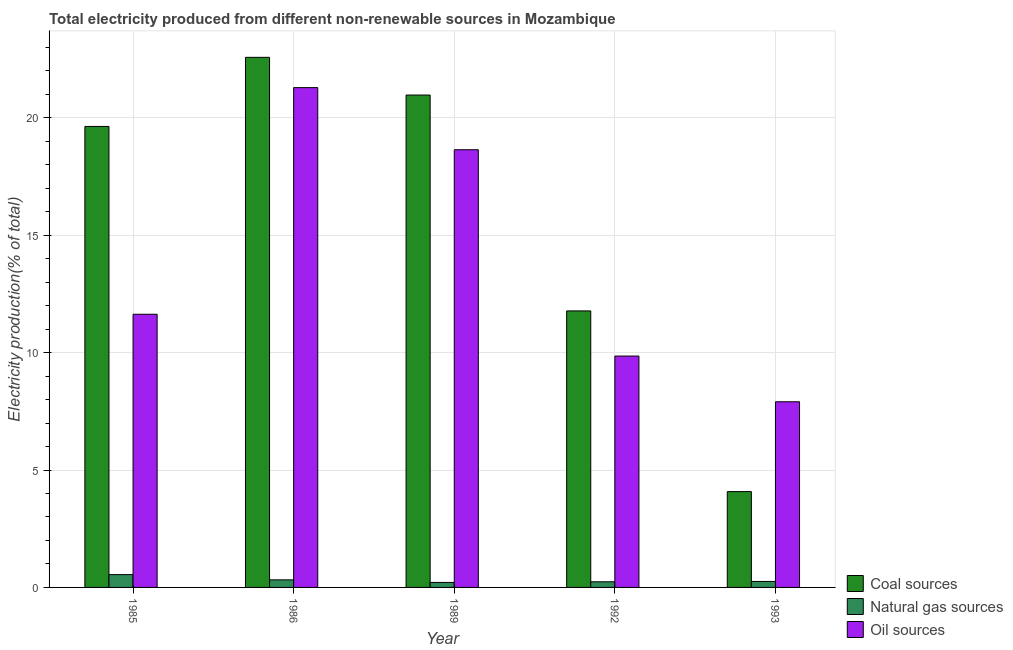How many groups of bars are there?
Your answer should be compact. 5. Are the number of bars per tick equal to the number of legend labels?
Keep it short and to the point. Yes. How many bars are there on the 1st tick from the right?
Keep it short and to the point. 3. What is the percentage of electricity produced by oil sources in 1986?
Your answer should be compact. 21.29. Across all years, what is the maximum percentage of electricity produced by natural gas?
Your answer should be very brief. 0.55. Across all years, what is the minimum percentage of electricity produced by oil sources?
Offer a very short reply. 7.91. In which year was the percentage of electricity produced by natural gas minimum?
Your answer should be compact. 1989. What is the total percentage of electricity produced by coal in the graph?
Keep it short and to the point. 79.05. What is the difference between the percentage of electricity produced by oil sources in 1989 and that in 1992?
Your answer should be very brief. 8.79. What is the difference between the percentage of electricity produced by oil sources in 1985 and the percentage of electricity produced by coal in 1992?
Your answer should be compact. 1.78. What is the average percentage of electricity produced by natural gas per year?
Ensure brevity in your answer.  0.32. In the year 1992, what is the difference between the percentage of electricity produced by natural gas and percentage of electricity produced by oil sources?
Keep it short and to the point. 0. What is the ratio of the percentage of electricity produced by oil sources in 1989 to that in 1992?
Keep it short and to the point. 1.89. Is the percentage of electricity produced by oil sources in 1985 less than that in 1993?
Provide a succinct answer. No. What is the difference between the highest and the second highest percentage of electricity produced by oil sources?
Ensure brevity in your answer.  2.65. What is the difference between the highest and the lowest percentage of electricity produced by oil sources?
Offer a terse response. 13.38. In how many years, is the percentage of electricity produced by oil sources greater than the average percentage of electricity produced by oil sources taken over all years?
Keep it short and to the point. 2. What does the 2nd bar from the left in 1993 represents?
Make the answer very short. Natural gas sources. What does the 1st bar from the right in 1993 represents?
Make the answer very short. Oil sources. Is it the case that in every year, the sum of the percentage of electricity produced by coal and percentage of electricity produced by natural gas is greater than the percentage of electricity produced by oil sources?
Your answer should be compact. No. How many years are there in the graph?
Make the answer very short. 5. What is the difference between two consecutive major ticks on the Y-axis?
Give a very brief answer. 5. Are the values on the major ticks of Y-axis written in scientific E-notation?
Provide a short and direct response. No. Does the graph contain grids?
Ensure brevity in your answer.  Yes. What is the title of the graph?
Keep it short and to the point. Total electricity produced from different non-renewable sources in Mozambique. What is the label or title of the X-axis?
Offer a very short reply. Year. What is the Electricity production(% of total) in Coal sources in 1985?
Offer a very short reply. 19.64. What is the Electricity production(% of total) of Natural gas sources in 1985?
Your answer should be very brief. 0.55. What is the Electricity production(% of total) of Oil sources in 1985?
Make the answer very short. 11.64. What is the Electricity production(% of total) of Coal sources in 1986?
Ensure brevity in your answer.  22.58. What is the Electricity production(% of total) of Natural gas sources in 1986?
Your answer should be very brief. 0.32. What is the Electricity production(% of total) of Oil sources in 1986?
Your answer should be compact. 21.29. What is the Electricity production(% of total) in Coal sources in 1989?
Your answer should be very brief. 20.97. What is the Electricity production(% of total) in Natural gas sources in 1989?
Ensure brevity in your answer.  0.21. What is the Electricity production(% of total) of Oil sources in 1989?
Your response must be concise. 18.64. What is the Electricity production(% of total) of Coal sources in 1992?
Offer a terse response. 11.78. What is the Electricity production(% of total) in Natural gas sources in 1992?
Keep it short and to the point. 0.24. What is the Electricity production(% of total) of Oil sources in 1992?
Your answer should be compact. 9.86. What is the Electricity production(% of total) in Coal sources in 1993?
Give a very brief answer. 4.08. What is the Electricity production(% of total) in Natural gas sources in 1993?
Offer a terse response. 0.26. What is the Electricity production(% of total) in Oil sources in 1993?
Your answer should be compact. 7.91. Across all years, what is the maximum Electricity production(% of total) in Coal sources?
Make the answer very short. 22.58. Across all years, what is the maximum Electricity production(% of total) of Natural gas sources?
Make the answer very short. 0.55. Across all years, what is the maximum Electricity production(% of total) of Oil sources?
Your response must be concise. 21.29. Across all years, what is the minimum Electricity production(% of total) in Coal sources?
Your answer should be compact. 4.08. Across all years, what is the minimum Electricity production(% of total) of Natural gas sources?
Provide a succinct answer. 0.21. Across all years, what is the minimum Electricity production(% of total) in Oil sources?
Give a very brief answer. 7.91. What is the total Electricity production(% of total) in Coal sources in the graph?
Your answer should be compact. 79.05. What is the total Electricity production(% of total) in Natural gas sources in the graph?
Keep it short and to the point. 1.58. What is the total Electricity production(% of total) in Oil sources in the graph?
Ensure brevity in your answer.  69.33. What is the difference between the Electricity production(% of total) of Coal sources in 1985 and that in 1986?
Provide a short and direct response. -2.94. What is the difference between the Electricity production(% of total) of Natural gas sources in 1985 and that in 1986?
Your answer should be very brief. 0.22. What is the difference between the Electricity production(% of total) of Oil sources in 1985 and that in 1986?
Ensure brevity in your answer.  -9.65. What is the difference between the Electricity production(% of total) of Coal sources in 1985 and that in 1989?
Give a very brief answer. -1.34. What is the difference between the Electricity production(% of total) in Natural gas sources in 1985 and that in 1989?
Your answer should be very brief. 0.33. What is the difference between the Electricity production(% of total) of Oil sources in 1985 and that in 1989?
Your answer should be very brief. -7.01. What is the difference between the Electricity production(% of total) of Coal sources in 1985 and that in 1992?
Provide a succinct answer. 7.86. What is the difference between the Electricity production(% of total) in Natural gas sources in 1985 and that in 1992?
Your answer should be very brief. 0.31. What is the difference between the Electricity production(% of total) of Oil sources in 1985 and that in 1992?
Offer a very short reply. 1.78. What is the difference between the Electricity production(% of total) of Coal sources in 1985 and that in 1993?
Your answer should be very brief. 15.55. What is the difference between the Electricity production(% of total) in Natural gas sources in 1985 and that in 1993?
Offer a very short reply. 0.29. What is the difference between the Electricity production(% of total) in Oil sources in 1985 and that in 1993?
Your answer should be compact. 3.73. What is the difference between the Electricity production(% of total) of Coal sources in 1986 and that in 1989?
Provide a short and direct response. 1.61. What is the difference between the Electricity production(% of total) of Natural gas sources in 1986 and that in 1989?
Offer a very short reply. 0.11. What is the difference between the Electricity production(% of total) in Oil sources in 1986 and that in 1989?
Make the answer very short. 2.65. What is the difference between the Electricity production(% of total) in Coal sources in 1986 and that in 1992?
Offer a very short reply. 10.8. What is the difference between the Electricity production(% of total) in Natural gas sources in 1986 and that in 1992?
Make the answer very short. 0.08. What is the difference between the Electricity production(% of total) in Oil sources in 1986 and that in 1992?
Give a very brief answer. 11.43. What is the difference between the Electricity production(% of total) of Coal sources in 1986 and that in 1993?
Offer a terse response. 18.5. What is the difference between the Electricity production(% of total) in Natural gas sources in 1986 and that in 1993?
Give a very brief answer. 0.07. What is the difference between the Electricity production(% of total) of Oil sources in 1986 and that in 1993?
Your answer should be very brief. 13.38. What is the difference between the Electricity production(% of total) of Coal sources in 1989 and that in 1992?
Give a very brief answer. 9.2. What is the difference between the Electricity production(% of total) of Natural gas sources in 1989 and that in 1992?
Your answer should be very brief. -0.03. What is the difference between the Electricity production(% of total) of Oil sources in 1989 and that in 1992?
Offer a very short reply. 8.79. What is the difference between the Electricity production(% of total) in Coal sources in 1989 and that in 1993?
Keep it short and to the point. 16.89. What is the difference between the Electricity production(% of total) of Natural gas sources in 1989 and that in 1993?
Provide a succinct answer. -0.04. What is the difference between the Electricity production(% of total) in Oil sources in 1989 and that in 1993?
Give a very brief answer. 10.74. What is the difference between the Electricity production(% of total) in Coal sources in 1992 and that in 1993?
Give a very brief answer. 7.7. What is the difference between the Electricity production(% of total) of Natural gas sources in 1992 and that in 1993?
Offer a very short reply. -0.01. What is the difference between the Electricity production(% of total) of Oil sources in 1992 and that in 1993?
Your response must be concise. 1.95. What is the difference between the Electricity production(% of total) in Coal sources in 1985 and the Electricity production(% of total) in Natural gas sources in 1986?
Make the answer very short. 19.31. What is the difference between the Electricity production(% of total) of Coal sources in 1985 and the Electricity production(% of total) of Oil sources in 1986?
Ensure brevity in your answer.  -1.65. What is the difference between the Electricity production(% of total) of Natural gas sources in 1985 and the Electricity production(% of total) of Oil sources in 1986?
Ensure brevity in your answer.  -20.74. What is the difference between the Electricity production(% of total) of Coal sources in 1985 and the Electricity production(% of total) of Natural gas sources in 1989?
Provide a short and direct response. 19.42. What is the difference between the Electricity production(% of total) of Coal sources in 1985 and the Electricity production(% of total) of Oil sources in 1989?
Provide a short and direct response. 0.99. What is the difference between the Electricity production(% of total) in Natural gas sources in 1985 and the Electricity production(% of total) in Oil sources in 1989?
Give a very brief answer. -18.1. What is the difference between the Electricity production(% of total) of Coal sources in 1985 and the Electricity production(% of total) of Natural gas sources in 1992?
Give a very brief answer. 19.4. What is the difference between the Electricity production(% of total) in Coal sources in 1985 and the Electricity production(% of total) in Oil sources in 1992?
Your answer should be very brief. 9.78. What is the difference between the Electricity production(% of total) of Natural gas sources in 1985 and the Electricity production(% of total) of Oil sources in 1992?
Your response must be concise. -9.31. What is the difference between the Electricity production(% of total) in Coal sources in 1985 and the Electricity production(% of total) in Natural gas sources in 1993?
Provide a succinct answer. 19.38. What is the difference between the Electricity production(% of total) in Coal sources in 1985 and the Electricity production(% of total) in Oil sources in 1993?
Your answer should be compact. 11.73. What is the difference between the Electricity production(% of total) of Natural gas sources in 1985 and the Electricity production(% of total) of Oil sources in 1993?
Ensure brevity in your answer.  -7.36. What is the difference between the Electricity production(% of total) of Coal sources in 1986 and the Electricity production(% of total) of Natural gas sources in 1989?
Your answer should be compact. 22.37. What is the difference between the Electricity production(% of total) of Coal sources in 1986 and the Electricity production(% of total) of Oil sources in 1989?
Provide a succinct answer. 3.94. What is the difference between the Electricity production(% of total) in Natural gas sources in 1986 and the Electricity production(% of total) in Oil sources in 1989?
Ensure brevity in your answer.  -18.32. What is the difference between the Electricity production(% of total) of Coal sources in 1986 and the Electricity production(% of total) of Natural gas sources in 1992?
Offer a terse response. 22.34. What is the difference between the Electricity production(% of total) in Coal sources in 1986 and the Electricity production(% of total) in Oil sources in 1992?
Provide a short and direct response. 12.72. What is the difference between the Electricity production(% of total) in Natural gas sources in 1986 and the Electricity production(% of total) in Oil sources in 1992?
Ensure brevity in your answer.  -9.53. What is the difference between the Electricity production(% of total) of Coal sources in 1986 and the Electricity production(% of total) of Natural gas sources in 1993?
Give a very brief answer. 22.33. What is the difference between the Electricity production(% of total) of Coal sources in 1986 and the Electricity production(% of total) of Oil sources in 1993?
Keep it short and to the point. 14.67. What is the difference between the Electricity production(% of total) in Natural gas sources in 1986 and the Electricity production(% of total) in Oil sources in 1993?
Your answer should be compact. -7.59. What is the difference between the Electricity production(% of total) of Coal sources in 1989 and the Electricity production(% of total) of Natural gas sources in 1992?
Offer a terse response. 20.73. What is the difference between the Electricity production(% of total) of Coal sources in 1989 and the Electricity production(% of total) of Oil sources in 1992?
Provide a short and direct response. 11.12. What is the difference between the Electricity production(% of total) in Natural gas sources in 1989 and the Electricity production(% of total) in Oil sources in 1992?
Provide a short and direct response. -9.64. What is the difference between the Electricity production(% of total) of Coal sources in 1989 and the Electricity production(% of total) of Natural gas sources in 1993?
Offer a terse response. 20.72. What is the difference between the Electricity production(% of total) in Coal sources in 1989 and the Electricity production(% of total) in Oil sources in 1993?
Provide a succinct answer. 13.07. What is the difference between the Electricity production(% of total) in Natural gas sources in 1989 and the Electricity production(% of total) in Oil sources in 1993?
Your answer should be compact. -7.7. What is the difference between the Electricity production(% of total) in Coal sources in 1992 and the Electricity production(% of total) in Natural gas sources in 1993?
Your answer should be compact. 11.52. What is the difference between the Electricity production(% of total) in Coal sources in 1992 and the Electricity production(% of total) in Oil sources in 1993?
Provide a short and direct response. 3.87. What is the difference between the Electricity production(% of total) of Natural gas sources in 1992 and the Electricity production(% of total) of Oil sources in 1993?
Provide a short and direct response. -7.67. What is the average Electricity production(% of total) of Coal sources per year?
Ensure brevity in your answer.  15.81. What is the average Electricity production(% of total) of Natural gas sources per year?
Ensure brevity in your answer.  0.32. What is the average Electricity production(% of total) in Oil sources per year?
Keep it short and to the point. 13.87. In the year 1985, what is the difference between the Electricity production(% of total) of Coal sources and Electricity production(% of total) of Natural gas sources?
Keep it short and to the point. 19.09. In the year 1985, what is the difference between the Electricity production(% of total) in Coal sources and Electricity production(% of total) in Oil sources?
Your answer should be compact. 8. In the year 1985, what is the difference between the Electricity production(% of total) in Natural gas sources and Electricity production(% of total) in Oil sources?
Provide a short and direct response. -11.09. In the year 1986, what is the difference between the Electricity production(% of total) in Coal sources and Electricity production(% of total) in Natural gas sources?
Offer a very short reply. 22.26. In the year 1986, what is the difference between the Electricity production(% of total) in Coal sources and Electricity production(% of total) in Oil sources?
Offer a very short reply. 1.29. In the year 1986, what is the difference between the Electricity production(% of total) of Natural gas sources and Electricity production(% of total) of Oil sources?
Your response must be concise. -20.97. In the year 1989, what is the difference between the Electricity production(% of total) of Coal sources and Electricity production(% of total) of Natural gas sources?
Ensure brevity in your answer.  20.76. In the year 1989, what is the difference between the Electricity production(% of total) of Coal sources and Electricity production(% of total) of Oil sources?
Make the answer very short. 2.33. In the year 1989, what is the difference between the Electricity production(% of total) in Natural gas sources and Electricity production(% of total) in Oil sources?
Keep it short and to the point. -18.43. In the year 1992, what is the difference between the Electricity production(% of total) of Coal sources and Electricity production(% of total) of Natural gas sources?
Your response must be concise. 11.54. In the year 1992, what is the difference between the Electricity production(% of total) in Coal sources and Electricity production(% of total) in Oil sources?
Provide a short and direct response. 1.92. In the year 1992, what is the difference between the Electricity production(% of total) in Natural gas sources and Electricity production(% of total) in Oil sources?
Provide a succinct answer. -9.62. In the year 1993, what is the difference between the Electricity production(% of total) in Coal sources and Electricity production(% of total) in Natural gas sources?
Provide a short and direct response. 3.83. In the year 1993, what is the difference between the Electricity production(% of total) of Coal sources and Electricity production(% of total) of Oil sources?
Make the answer very short. -3.83. In the year 1993, what is the difference between the Electricity production(% of total) in Natural gas sources and Electricity production(% of total) in Oil sources?
Offer a very short reply. -7.65. What is the ratio of the Electricity production(% of total) of Coal sources in 1985 to that in 1986?
Make the answer very short. 0.87. What is the ratio of the Electricity production(% of total) of Natural gas sources in 1985 to that in 1986?
Give a very brief answer. 1.69. What is the ratio of the Electricity production(% of total) in Oil sources in 1985 to that in 1986?
Give a very brief answer. 0.55. What is the ratio of the Electricity production(% of total) in Coal sources in 1985 to that in 1989?
Offer a very short reply. 0.94. What is the ratio of the Electricity production(% of total) of Natural gas sources in 1985 to that in 1989?
Give a very brief answer. 2.57. What is the ratio of the Electricity production(% of total) of Oil sources in 1985 to that in 1989?
Offer a very short reply. 0.62. What is the ratio of the Electricity production(% of total) of Coal sources in 1985 to that in 1992?
Make the answer very short. 1.67. What is the ratio of the Electricity production(% of total) in Natural gas sources in 1985 to that in 1992?
Give a very brief answer. 2.27. What is the ratio of the Electricity production(% of total) of Oil sources in 1985 to that in 1992?
Your answer should be compact. 1.18. What is the ratio of the Electricity production(% of total) in Coal sources in 1985 to that in 1993?
Ensure brevity in your answer.  4.81. What is the ratio of the Electricity production(% of total) of Natural gas sources in 1985 to that in 1993?
Offer a very short reply. 2.14. What is the ratio of the Electricity production(% of total) in Oil sources in 1985 to that in 1993?
Give a very brief answer. 1.47. What is the ratio of the Electricity production(% of total) of Coal sources in 1986 to that in 1989?
Make the answer very short. 1.08. What is the ratio of the Electricity production(% of total) in Natural gas sources in 1986 to that in 1989?
Keep it short and to the point. 1.52. What is the ratio of the Electricity production(% of total) in Oil sources in 1986 to that in 1989?
Offer a very short reply. 1.14. What is the ratio of the Electricity production(% of total) in Coal sources in 1986 to that in 1992?
Ensure brevity in your answer.  1.92. What is the ratio of the Electricity production(% of total) in Natural gas sources in 1986 to that in 1992?
Give a very brief answer. 1.34. What is the ratio of the Electricity production(% of total) of Oil sources in 1986 to that in 1992?
Provide a short and direct response. 2.16. What is the ratio of the Electricity production(% of total) in Coal sources in 1986 to that in 1993?
Your answer should be very brief. 5.53. What is the ratio of the Electricity production(% of total) of Natural gas sources in 1986 to that in 1993?
Offer a terse response. 1.26. What is the ratio of the Electricity production(% of total) in Oil sources in 1986 to that in 1993?
Your answer should be compact. 2.69. What is the ratio of the Electricity production(% of total) in Coal sources in 1989 to that in 1992?
Ensure brevity in your answer.  1.78. What is the ratio of the Electricity production(% of total) in Natural gas sources in 1989 to that in 1992?
Provide a short and direct response. 0.88. What is the ratio of the Electricity production(% of total) in Oil sources in 1989 to that in 1992?
Keep it short and to the point. 1.89. What is the ratio of the Electricity production(% of total) of Coal sources in 1989 to that in 1993?
Offer a terse response. 5.14. What is the ratio of the Electricity production(% of total) of Natural gas sources in 1989 to that in 1993?
Ensure brevity in your answer.  0.83. What is the ratio of the Electricity production(% of total) of Oil sources in 1989 to that in 1993?
Ensure brevity in your answer.  2.36. What is the ratio of the Electricity production(% of total) in Coal sources in 1992 to that in 1993?
Your answer should be very brief. 2.89. What is the ratio of the Electricity production(% of total) in Natural gas sources in 1992 to that in 1993?
Offer a terse response. 0.94. What is the ratio of the Electricity production(% of total) of Oil sources in 1992 to that in 1993?
Ensure brevity in your answer.  1.25. What is the difference between the highest and the second highest Electricity production(% of total) of Coal sources?
Your answer should be very brief. 1.61. What is the difference between the highest and the second highest Electricity production(% of total) in Natural gas sources?
Make the answer very short. 0.22. What is the difference between the highest and the second highest Electricity production(% of total) of Oil sources?
Your response must be concise. 2.65. What is the difference between the highest and the lowest Electricity production(% of total) of Coal sources?
Ensure brevity in your answer.  18.5. What is the difference between the highest and the lowest Electricity production(% of total) of Natural gas sources?
Your answer should be compact. 0.33. What is the difference between the highest and the lowest Electricity production(% of total) of Oil sources?
Your answer should be very brief. 13.38. 